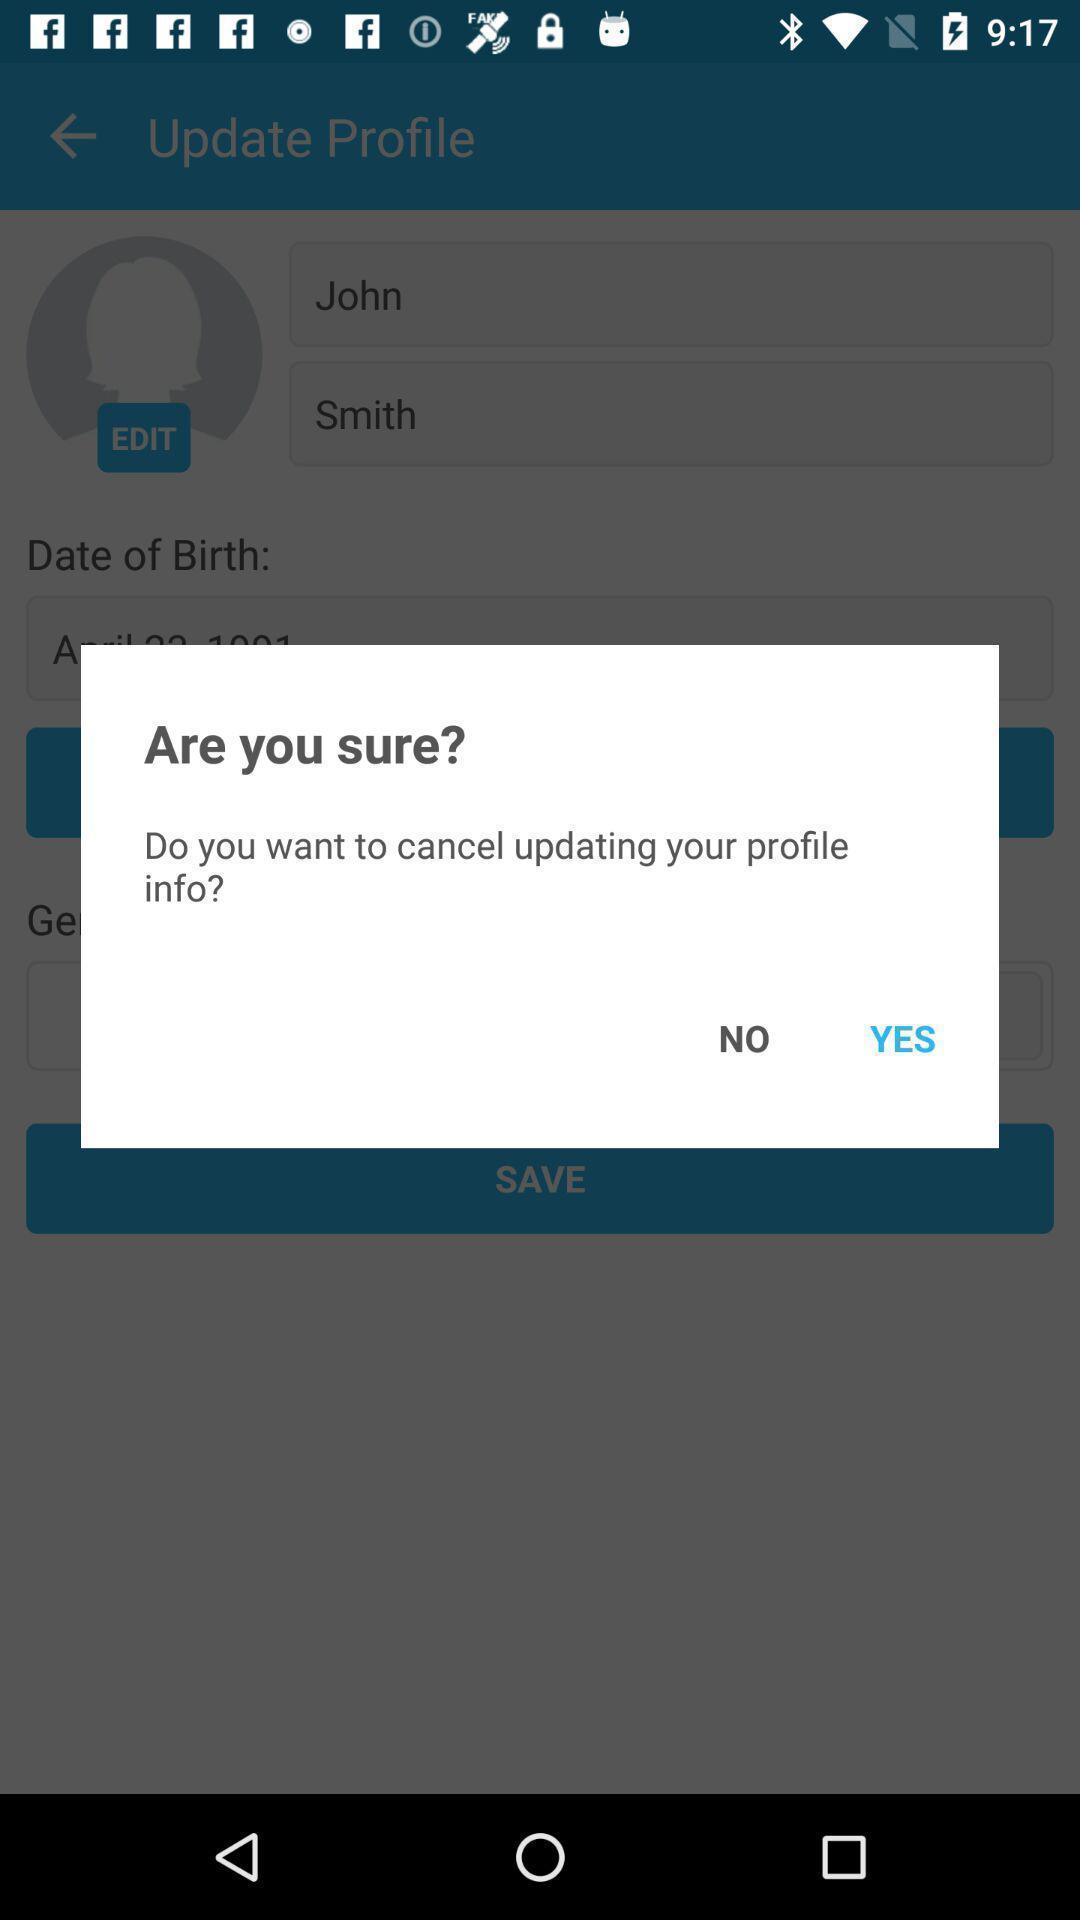Summarize the information in this screenshot. Pop-up displaying to confirm updating an app. 